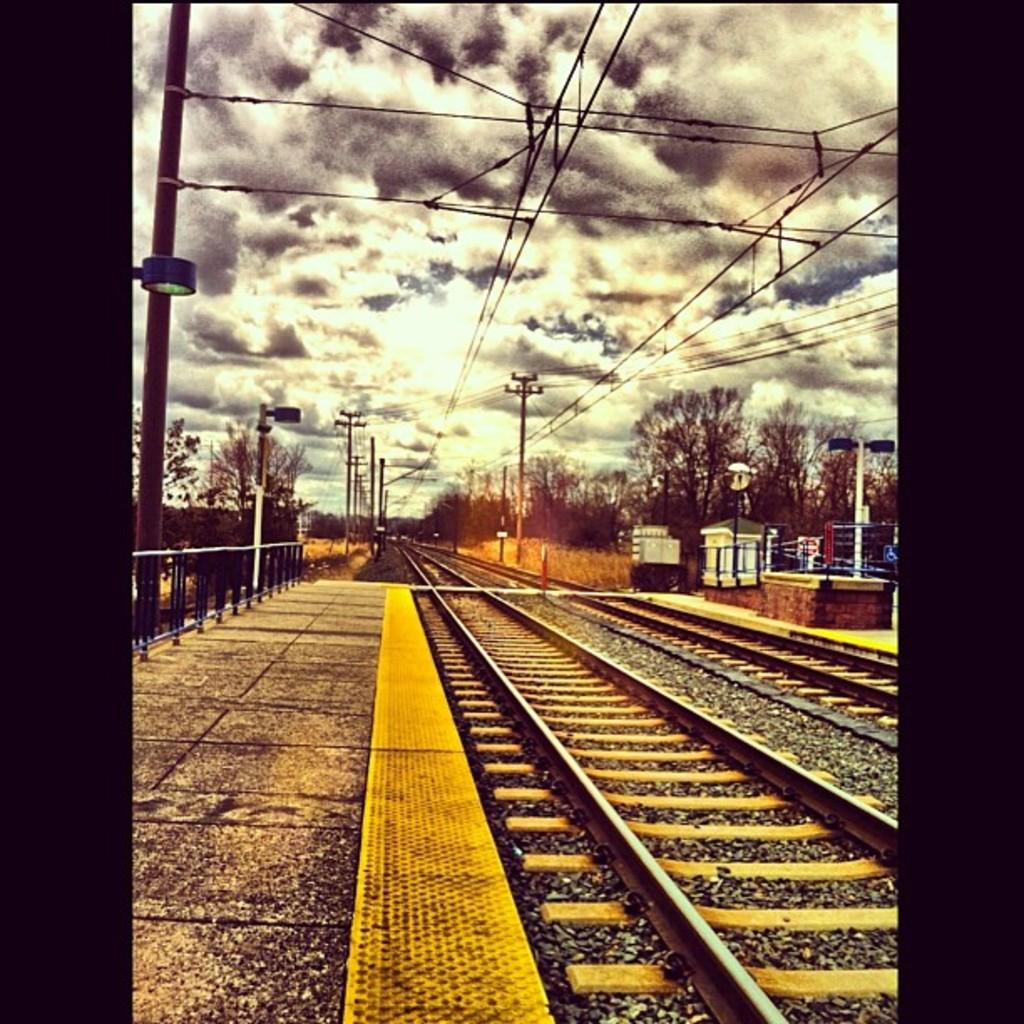What type of transportation infrastructure is visible in the image? There are railway tracks in the image. What is located near the railway tracks? There is a fence and a platform in the image. What are the poles used for in the image? The poles are likely used to support electric wires. What is the small structure on the right side of the image? There is a small shed on the right side of the image. What type of natural elements can be seen in the image? Trees are present in the image, and clouds are visible in the sky. What finger is being used to point at the space station in the image? There is no finger or space station present in the image. 